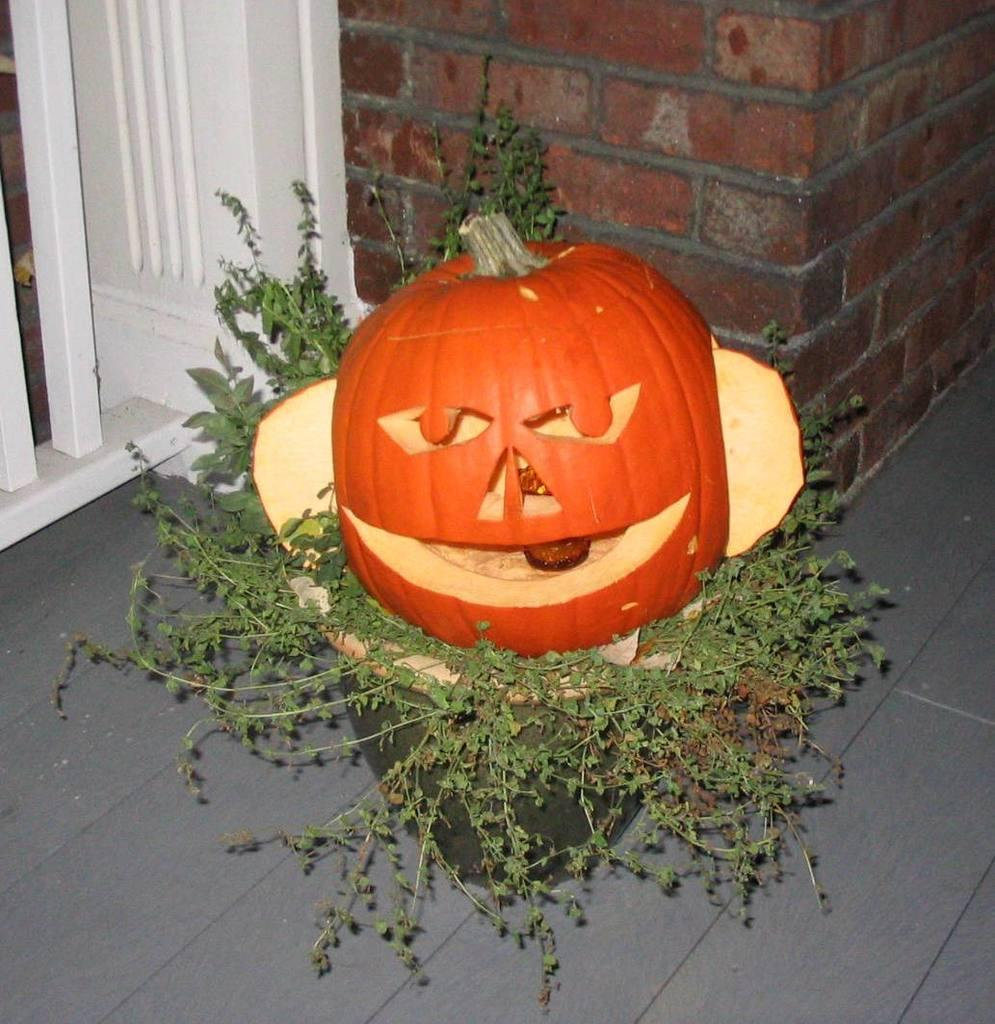What is placed on the potted plant in the image? There is a fruit placed on a potted plant in the image. What can be seen in the background of the image? There is a brick wall in the background of the image. What type of polish is being used on the tin in the image? There is no tin or polish present in the image; it only features a fruit placed on a potted plant and a brick wall in the background. Where in the house might this image have been taken? The image does not provide enough context to determine the specific room or location within the house, such as a bedroom. 